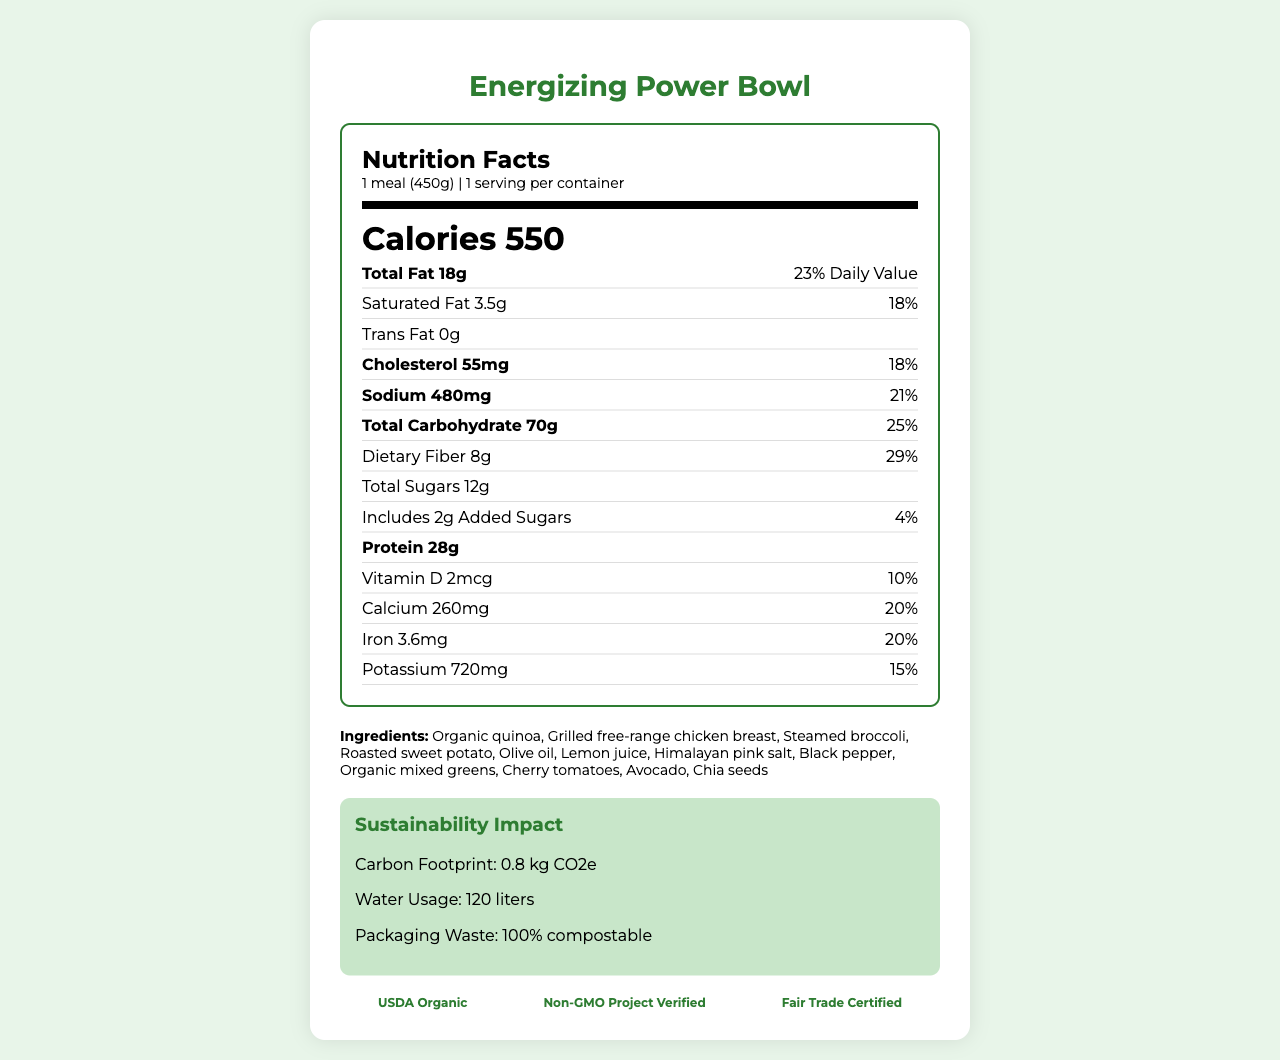what is the total fat content in the meal? The document specifies that the meal contains 18g of total fat.
Answer: 18g What percentage of the daily value does the protein content represent? The document states that the protein content represents 56% of the daily value.
Answer: 56% How much dietary fiber is included in the meal? The document lists that the meal contains 8g of dietary fiber.
Answer: 8g What is the sodium content of the meal? The document specifies that the sodium content is 480mg.
Answer: 480mg What is the serving size of the meal? The document states that the serving size is 1 meal (450g).
Answer: 1 meal (450g) Which of the following certifications does the meal have? A. USDA Organic B. Non-GMO Project Verified C. Fair Trade Certified D. All of the above The document lists all these certifications: USDA Organic, Non-GMO Project Verified, and Fair Trade Certified.
Answer: D What is the amount of total sugars in the meal? A. 8g B. 10g C. 12g D. 14g The document states that the meal contains 12g of total sugars.
Answer: C Can this meal be considered allergen-free? The document mentions that the meal contains no allergens.
Answer: Yes Summarize the main idea of this document. The "Energizing Power Bowl" is presented with specific nutritional information, a list of ingredients, sustainability considerations, and certifications, highlighting its health benefits and commitment to environmental sustainability.
Answer: The document describes the "Energizing Power Bowl", detailing its nutrition facts, ingredients, sustainability impact, and certifications, emphasizing its balanced nutrition and environmentally friendly aspects. What is the preparation method mentioned for chicken in the ingredient list? The chicken is listed as "Grilled free-range chicken breast" in the ingredients.
Answer: Grilled What is the calorie content of the meal? The document states that the meal contains 550 calories.
Answer: 550 calories What is the daily value percentage of saturated fat in the meal? The document specifies that 3.5g of saturated fat is 18% of the daily value.
Answer: 18% What are the special features of this meal? A. Organic ingredients B. Eco-friendly packaging C. Locally grown produce D. All of the above The document lists special features such as sustainably sourced ingredients, locally grown produce, eco-friendly packaging, and carbon-neutral meal preparation.
Answer: D How much calcium is in the meal? The document states that the meal contains 260mg of calcium, which is 20% of the daily value.
Answer: 260mg Does the document mention the meal supporting mental well-being? The document mentions supporting overall wellness and sustained energy but does not specifically mention mental well-being.
Answer: Not enough information 